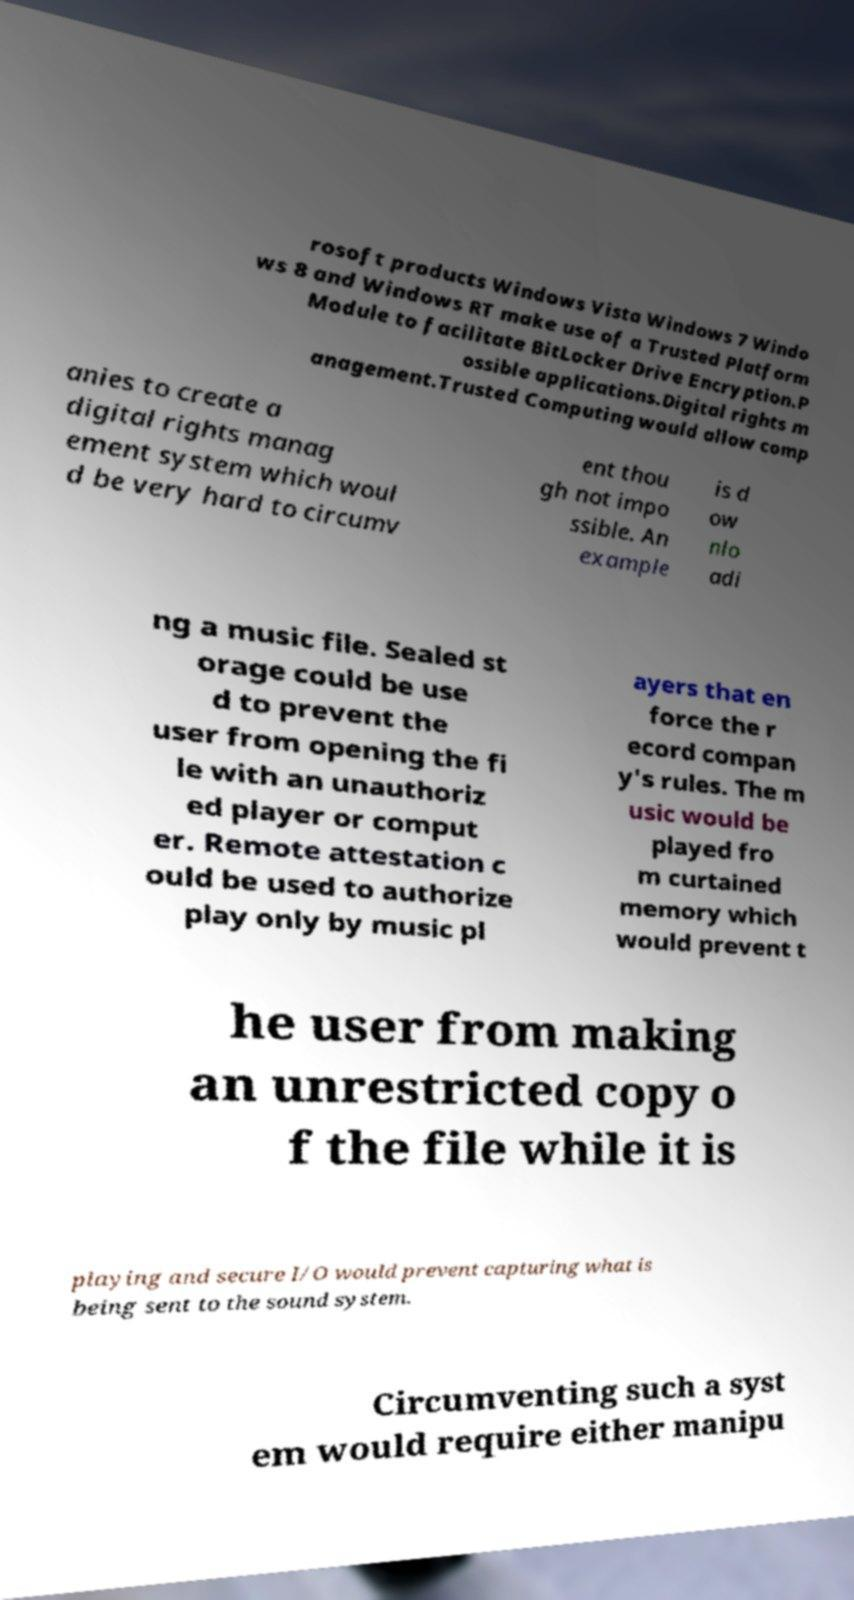For documentation purposes, I need the text within this image transcribed. Could you provide that? rosoft products Windows Vista Windows 7 Windo ws 8 and Windows RT make use of a Trusted Platform Module to facilitate BitLocker Drive Encryption.P ossible applications.Digital rights m anagement.Trusted Computing would allow comp anies to create a digital rights manag ement system which woul d be very hard to circumv ent thou gh not impo ssible. An example is d ow nlo adi ng a music file. Sealed st orage could be use d to prevent the user from opening the fi le with an unauthoriz ed player or comput er. Remote attestation c ould be used to authorize play only by music pl ayers that en force the r ecord compan y's rules. The m usic would be played fro m curtained memory which would prevent t he user from making an unrestricted copy o f the file while it is playing and secure I/O would prevent capturing what is being sent to the sound system. Circumventing such a syst em would require either manipu 